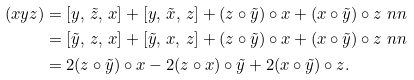<formula> <loc_0><loc_0><loc_500><loc_500>( x y z ) & = [ y , \, \tilde { z } , \, x ] + [ y , \, \tilde { x } , \, z ] + ( z \circ { \tilde { y } } ) \circ x + ( x \circ { \tilde { y } } ) \circ z \ n n \\ & = [ \tilde { y } , \, z , \, x ] + [ \tilde { y } , \, x , \, z ] + ( z \circ { \tilde { y } } ) \circ x + ( x \circ { \tilde { y } } ) \circ z \ n n \\ & = 2 ( z \circ \tilde { y } ) \circ x - 2 ( z \circ x ) \circ \tilde { y } + 2 ( x \circ \tilde { y } ) \circ z .</formula> 